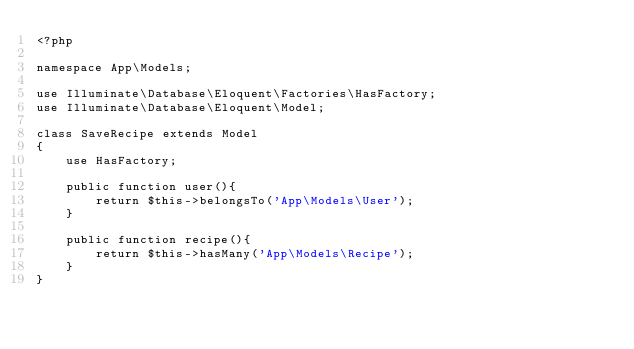<code> <loc_0><loc_0><loc_500><loc_500><_PHP_><?php

namespace App\Models;

use Illuminate\Database\Eloquent\Factories\HasFactory;
use Illuminate\Database\Eloquent\Model;

class SaveRecipe extends Model
{
    use HasFactory;

    public function user(){
        return $this->belongsTo('App\Models\User');
    }

    public function recipe(){
        return $this->hasMany('App\Models\Recipe');
    }
}
</code> 